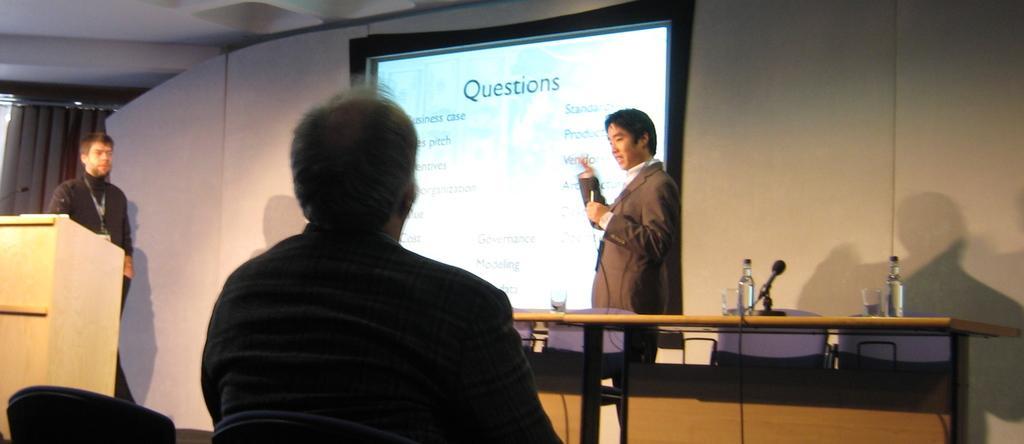In one or two sentences, can you explain what this image depicts? This person is standing and holding a mic. A screen is attached to a wall. On this table there are bottles, glasses and mic. This are chairs. This person is sitting on a chair. This person is standing. In-front of this person there is a podium with mic. 